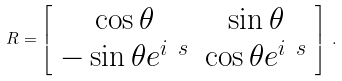Convert formula to latex. <formula><loc_0><loc_0><loc_500><loc_500>R = \left [ \begin{array} { c c } \cos { \theta } & \sin { \theta } \\ - \sin { \theta } e ^ { i \ s } & \cos { \theta } e ^ { i \ s } \end{array} \right ] \, .</formula> 